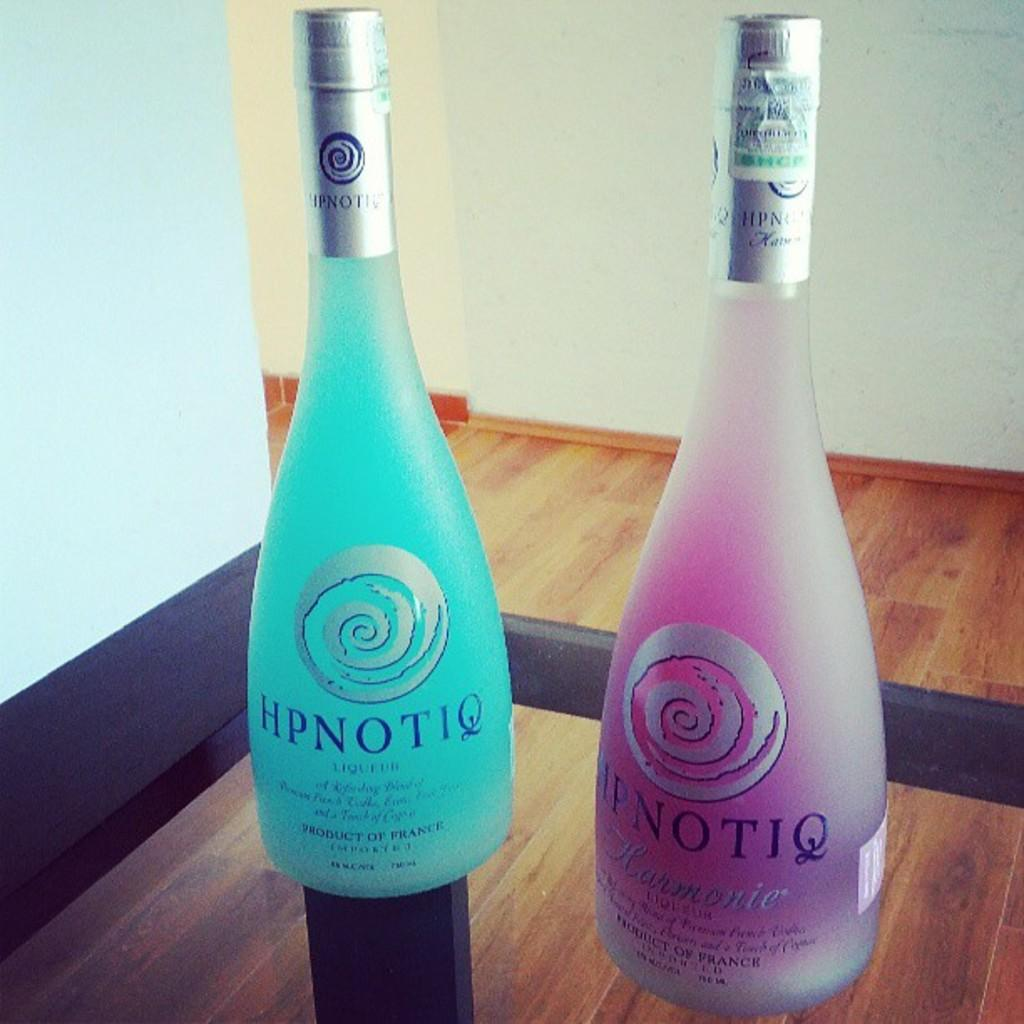<image>
Create a compact narrative representing the image presented. Two colorful bottles have the name Hpnotiq on them. 